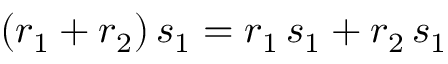<formula> <loc_0><loc_0><loc_500><loc_500>( r _ { 1 } + r _ { 2 } ) \, s _ { 1 } = r _ { 1 } \, s _ { 1 } + r _ { 2 } \, s _ { 1 }</formula> 